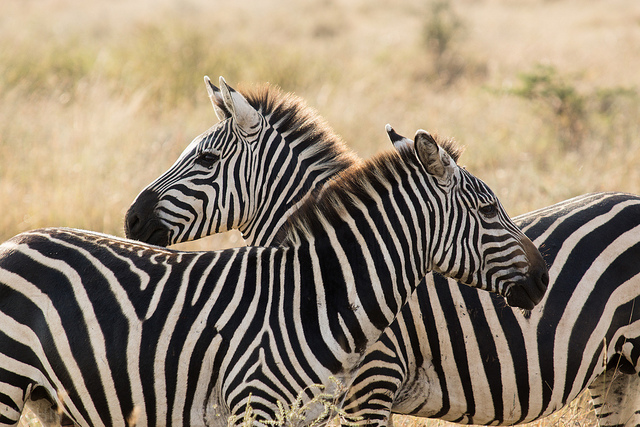Are the zebras in a zoo? No, the zebras are not in a zoo. 